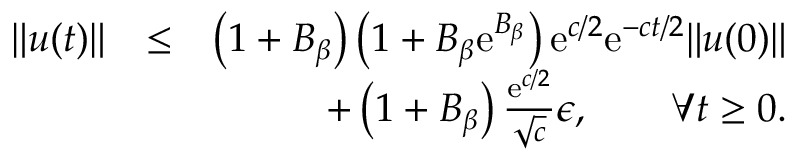Convert formula to latex. <formula><loc_0><loc_0><loc_500><loc_500>\begin{array} { r l r } { \| u ( t ) \| } & { \leq } & { \left ( 1 + B _ { \beta } \right ) \left ( 1 + B _ { \beta } e ^ { B _ { \beta } } \right ) e ^ { c / 2 } e ^ { - c t / 2 } \| u ( 0 ) \| } \\ & { + \left ( 1 + B _ { \beta } \right ) { \frac { e ^ { c / 2 } } { \sqrt { c } } } \epsilon , \quad \forall t \geq 0 . } \end{array}</formula> 